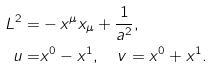<formula> <loc_0><loc_0><loc_500><loc_500>L ^ { 2 } = & - x ^ { \mu } x _ { \mu } + \frac { 1 } { a ^ { 2 } } , \\ u = & x ^ { 0 } - x ^ { 1 } , \quad v = x ^ { 0 } + x ^ { 1 } .</formula> 